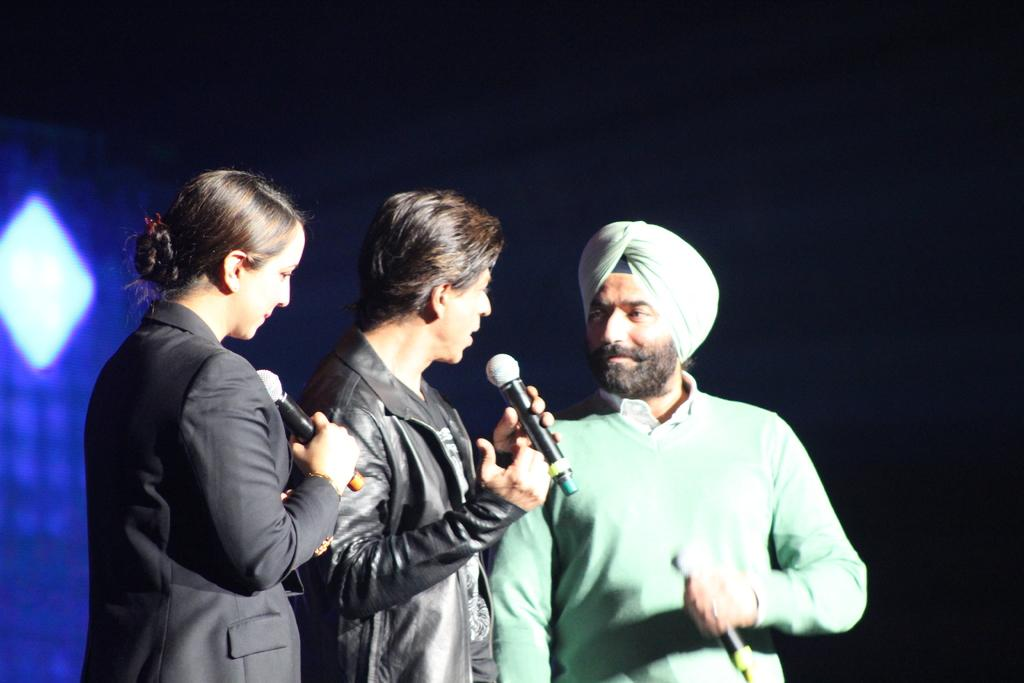How many people are in the image? There are three people in the image. What are the people doing in the image? The people are standing and holding a mic in their hand. Can you describe the background of the image? There is a light in the background of the image. What type of territory is being discussed by the people in the image? There is no indication in the image that the people are discussing any territory. 